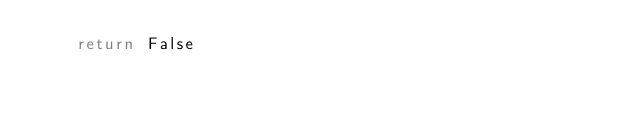<code> <loc_0><loc_0><loc_500><loc_500><_Python_>    return False
    </code> 